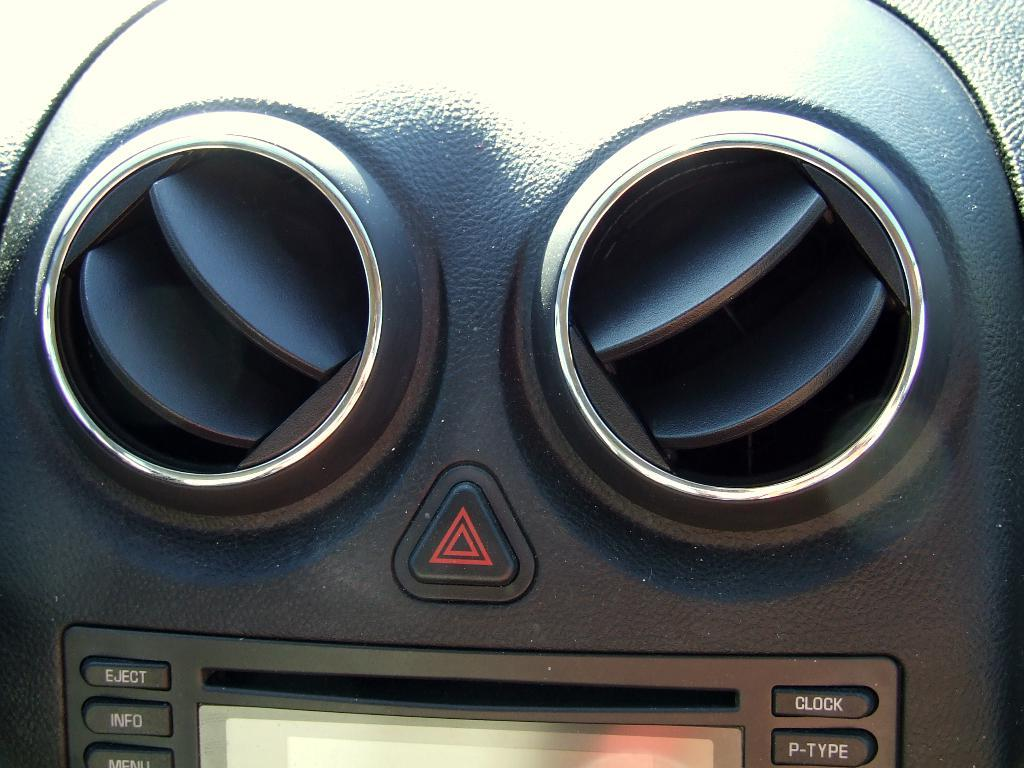Where was the image taken? The image was taken inside a car. What can be seen on the dashboard of the car? There are two AC vents visible in the image. Are there any controls or switches visible in the image? Yes, there are a few buttons visible in the image. What type of oatmeal is being served to the sheep in the image? There is no oatmeal or sheep present in the image; it was taken inside a car. 